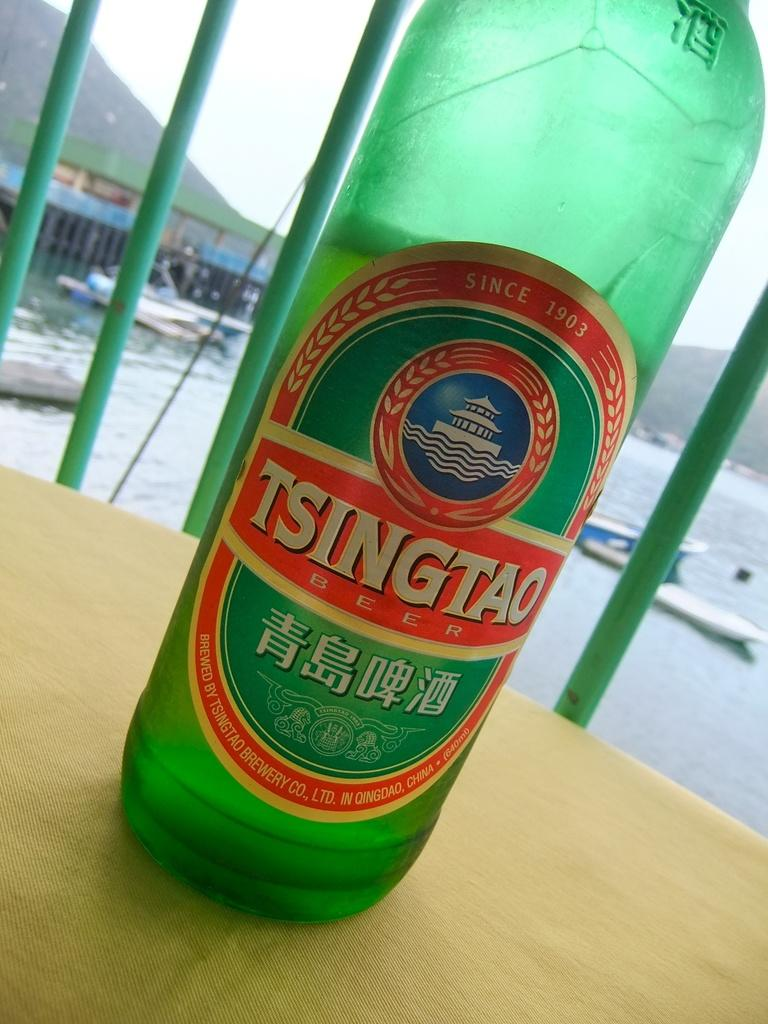<image>
Present a compact description of the photo's key features. Tsingtao bottle in front of a background with water and ships. 